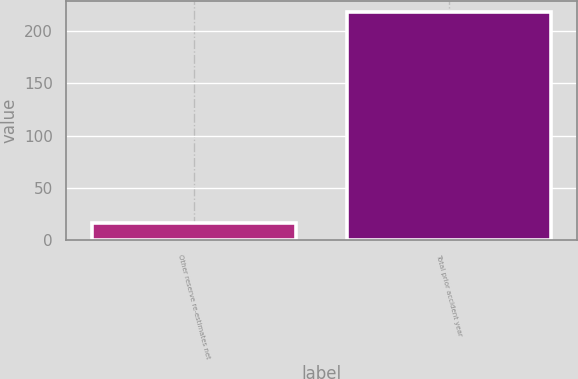Convert chart. <chart><loc_0><loc_0><loc_500><loc_500><bar_chart><fcel>Other reserve re-estimates net<fcel>Total prior accident year<nl><fcel>17<fcel>218<nl></chart> 